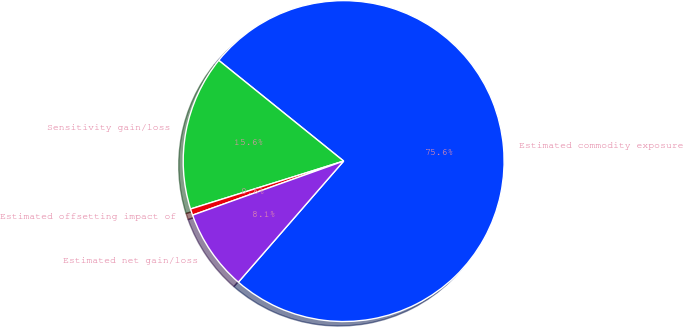Convert chart to OTSL. <chart><loc_0><loc_0><loc_500><loc_500><pie_chart><fcel>Estimated commodity exposure<fcel>Sensitivity gain/loss<fcel>Estimated offsetting impact of<fcel>Estimated net gain/loss<nl><fcel>75.59%<fcel>15.63%<fcel>0.64%<fcel>8.14%<nl></chart> 